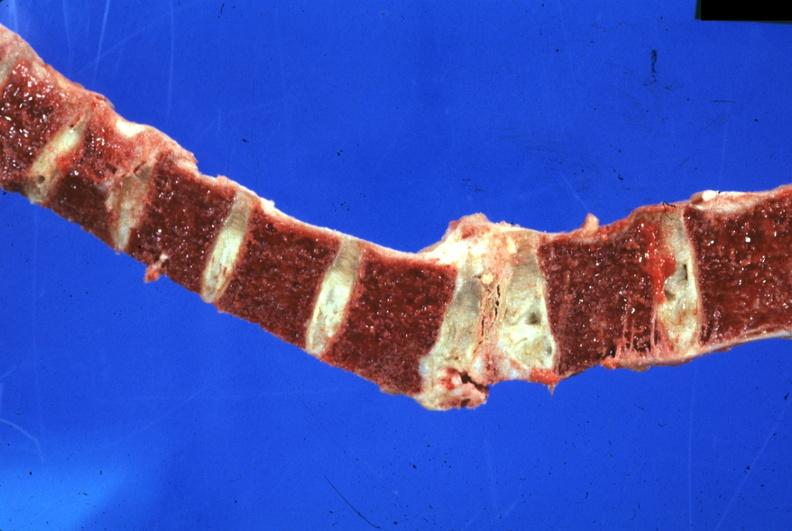s joints present?
Answer the question using a single word or phrase. Yes 